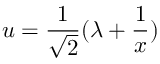<formula> <loc_0><loc_0><loc_500><loc_500>u = \frac { 1 } { \sqrt { 2 } } ( \lambda + \frac { 1 } { x } )</formula> 